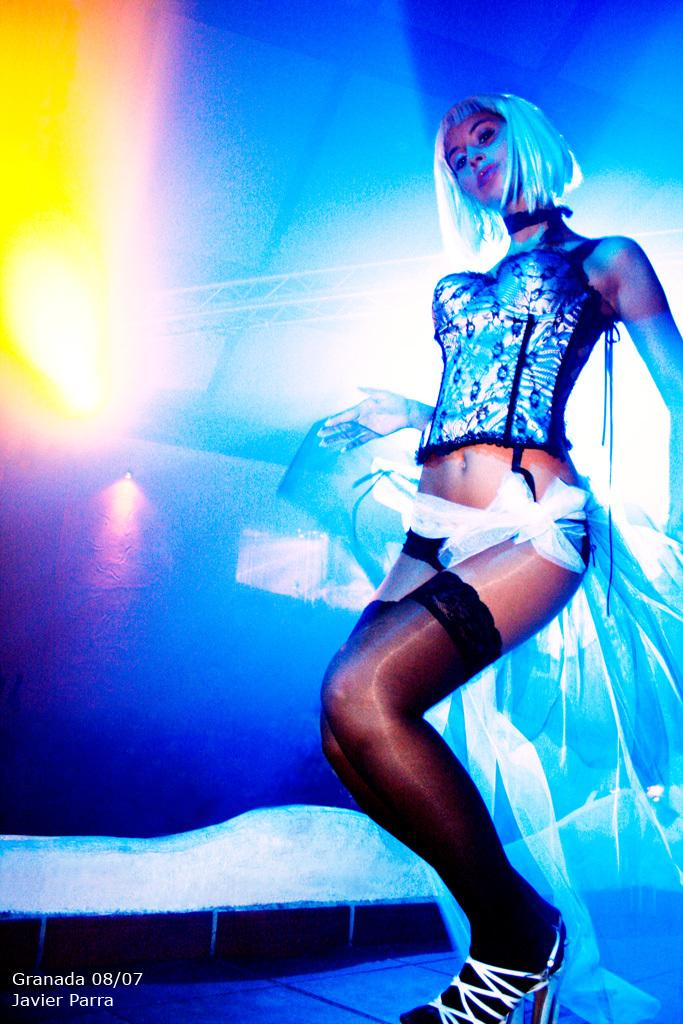Who is present in the image? There is a woman in the image. What is the woman wearing? The woman is wearing a dress. What is the woman's position in the image? The woman is standing on the floor. What can be seen in the background of the image? There are lights and poles in the background of the image. What type of curtain is hanging from the yoke in the image? There is no yoke or curtain present in the image. How many cows are visible in the image? There are no cows present in the image. 